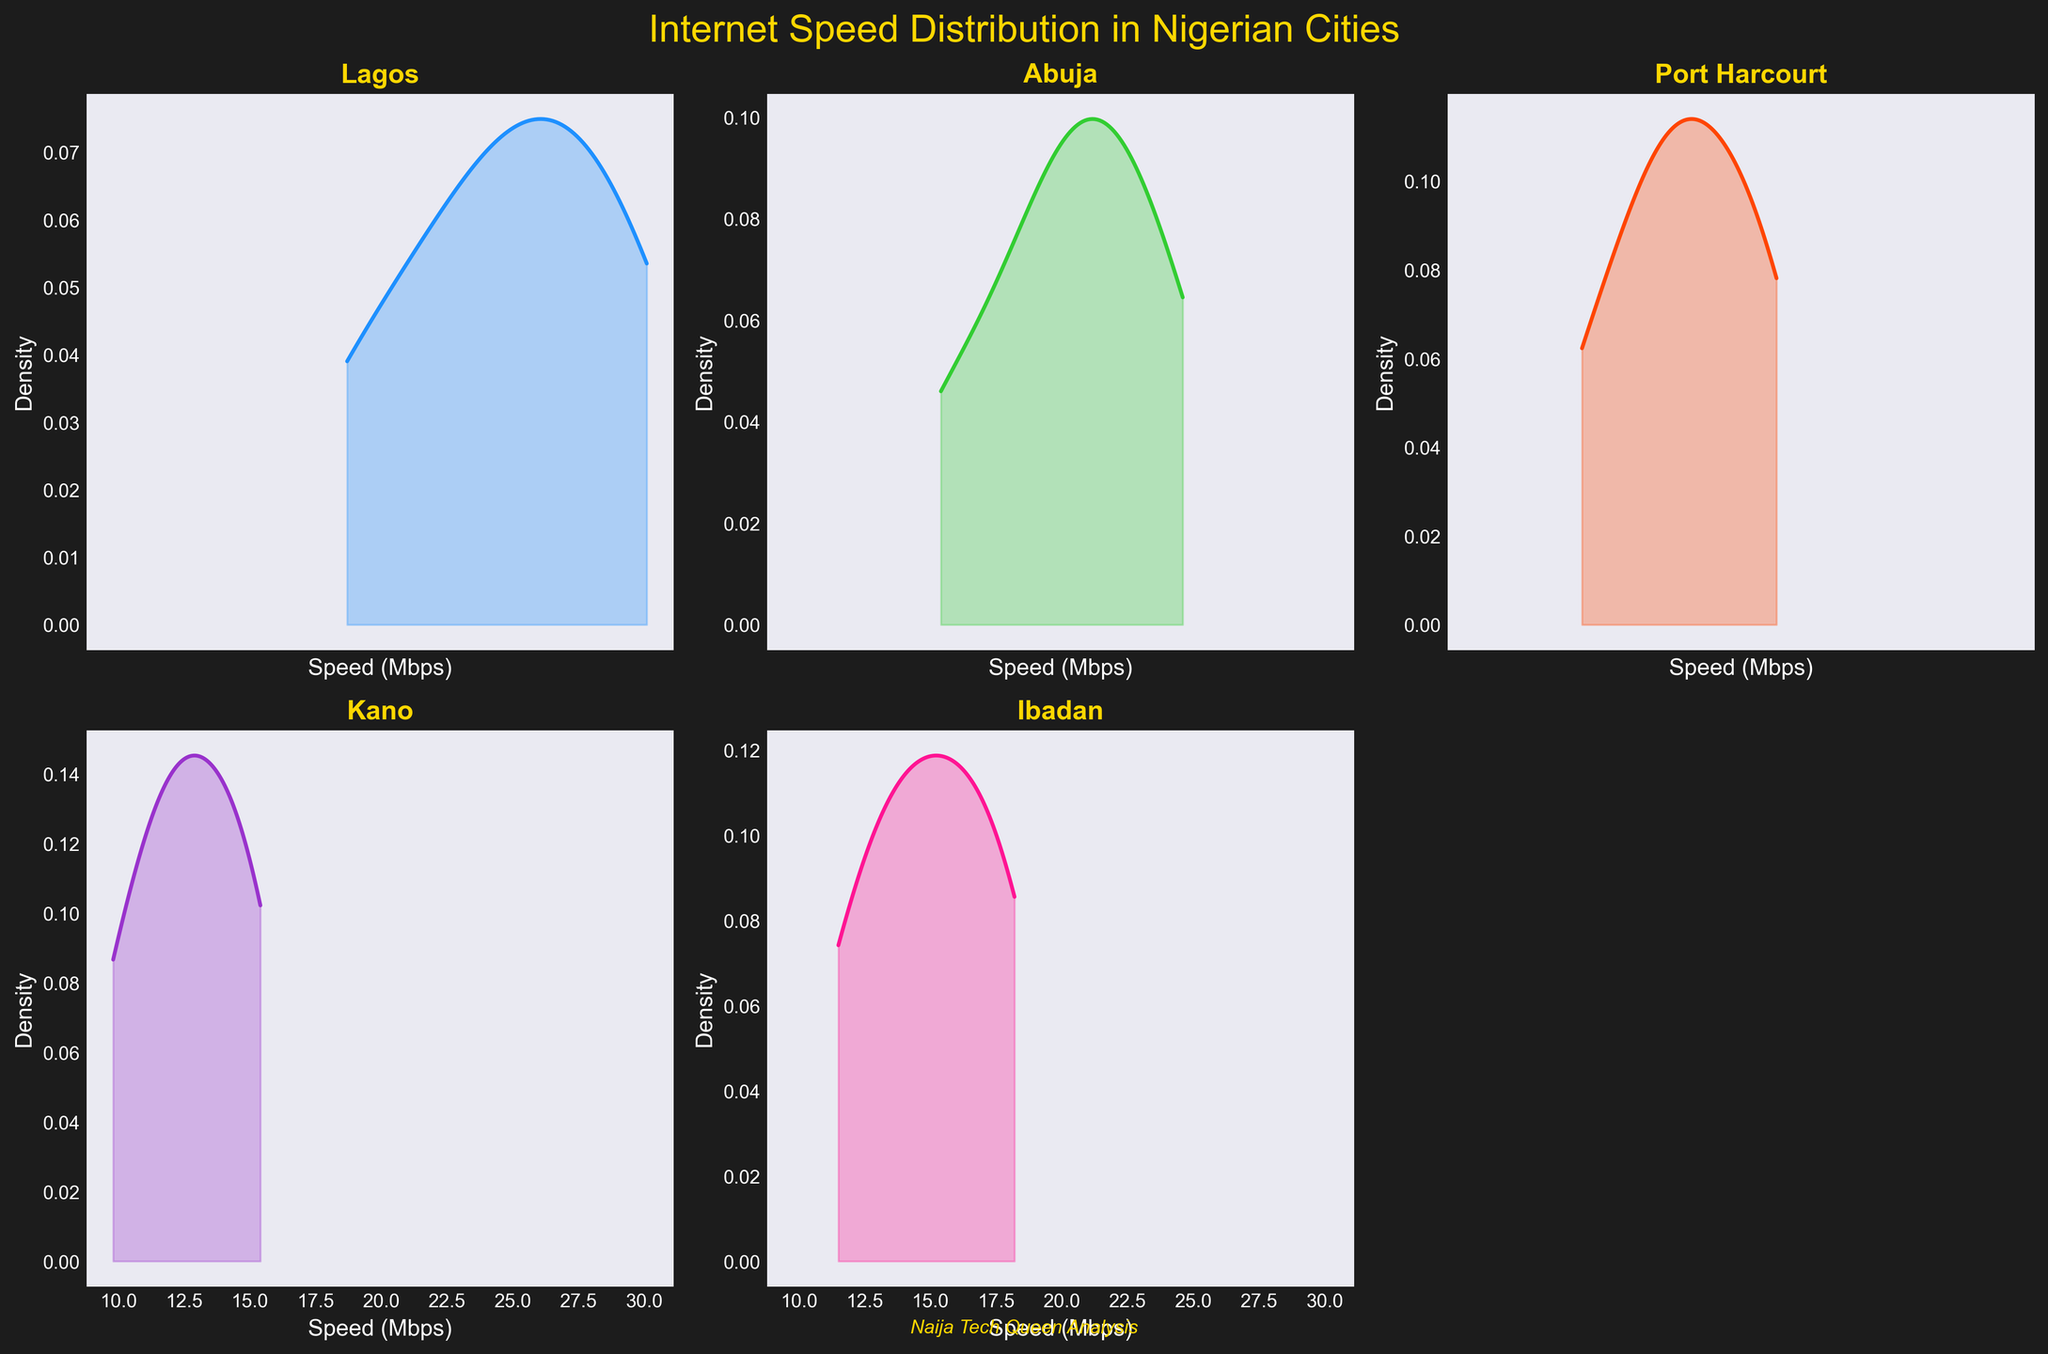Which city has the highest internet speed density peak? From the density plots, the highest peak represents the most common speed in that city. Visually, Lagos appears to have the highest peak compared to the other cities.
Answer: Lagos What is the approximate range of internet speeds in Abuja? The speeds in Abuja range from the minimum to the maximum point of the density plot. Visually, this ranges from around 15 to 25 Mbps.
Answer: 15-25 Mbps Which city shows the widest spread in internet speeds? The widest spread is observed by comparing the range of densities from the lowest to the highest values across cities. Kano appears to have the most spread out speeds, from around 10 to 15 Mbps.
Answer: Kano Is the average internet speed in Port Harcourt higher than in Ibadan? By estimating the centers of the density plots, Port Harcourt's average speed seems slightly lower than Ibadan's range. Visually, Ibadan has a higher average speed compared to Port Harcourt.
Answer: No Which city among Lagos and Kano has more consistent internet speeds? A more consistent speed range indicates a higher peak and narrower spread in the density plot. Lagos shows higher consistency with a tight range around a high peak.
Answer: Lagos Which city has the lowest peak density in its internet speed distribution plot? The lowest peak can be seen by identifying the city with the flattest distribution curve. Kano's plot shows the least pronounced peak, indicating the lowest density.
Answer: Kano How similar are the internet speeds in Ibadan compared to Abuja? Observing the shapes and scale of the density plots helps compare similarities. Ibadan and Abuja both have center peaks around similar speeds, suggesting similar overall speeds.
Answer: Similar What can you infer about the consistency of internet speeds in Lagos compared to Ibadan? The consistency of internet speeds can be inferred by looking at the spread and peak sharpness of the density plots. Lagos has a sharp, high peak indicating more consistent speeds compared to Ibadan's wider distribution.
Answer: More consistent in Lagos 